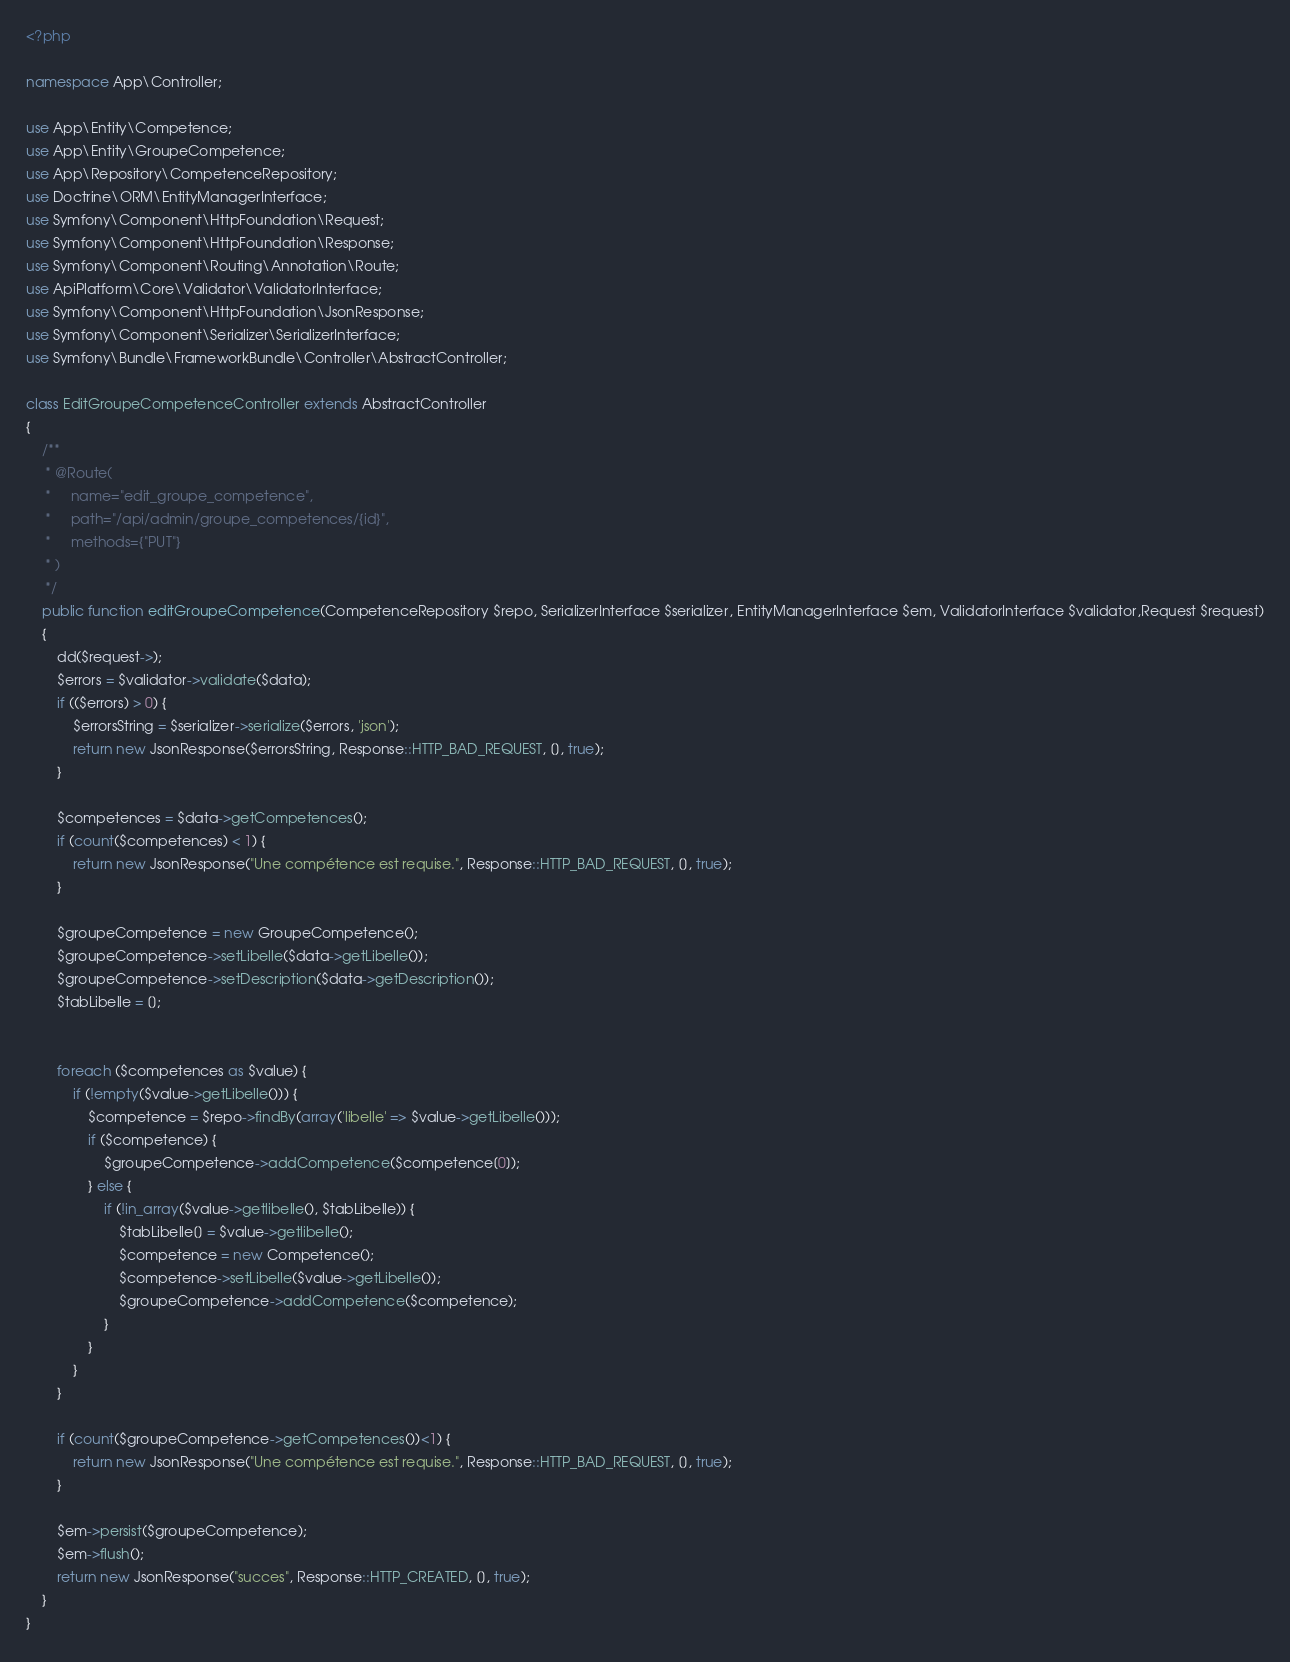<code> <loc_0><loc_0><loc_500><loc_500><_PHP_><?php

namespace App\Controller;

use App\Entity\Competence;
use App\Entity\GroupeCompetence;
use App\Repository\CompetenceRepository;
use Doctrine\ORM\EntityManagerInterface;
use Symfony\Component\HttpFoundation\Request;
use Symfony\Component\HttpFoundation\Response;
use Symfony\Component\Routing\Annotation\Route;
use ApiPlatform\Core\Validator\ValidatorInterface;
use Symfony\Component\HttpFoundation\JsonResponse;
use Symfony\Component\Serializer\SerializerInterface;
use Symfony\Bundle\FrameworkBundle\Controller\AbstractController;

class EditGroupeCompetenceController extends AbstractController
{
    /**
     * @Route(
     *     name="edit_groupe_competence",
     *     path="/api/admin/groupe_competences/{id}",
     *     methods={"PUT"}
     * )
     */
    public function editGroupeCompetence(CompetenceRepository $repo, SerializerInterface $serializer, EntityManagerInterface $em, ValidatorInterface $validator,Request $request)
    {
        dd($request->);
        $errors = $validator->validate($data);
        if (($errors) > 0) {
            $errorsString = $serializer->serialize($errors, 'json');
            return new JsonResponse($errorsString, Response::HTTP_BAD_REQUEST, [], true);
        }

        $competences = $data->getCompetences();
        if (count($competences) < 1) {
            return new JsonResponse("Une compétence est requise.", Response::HTTP_BAD_REQUEST, [], true);
        }

        $groupeCompetence = new GroupeCompetence();
        $groupeCompetence->setLibelle($data->getLibelle());
        $groupeCompetence->setDescription($data->getDescription());
        $tabLibelle = [];


        foreach ($competences as $value) {
            if (!empty($value->getLibelle())) {
                $competence = $repo->findBy(array('libelle' => $value->getLibelle()));
                if ($competence) {
                    $groupeCompetence->addCompetence($competence[0]);
                } else {
                    if (!in_array($value->getlibelle(), $tabLibelle)) {
                        $tabLibelle[] = $value->getlibelle();
                        $competence = new Competence();
                        $competence->setLibelle($value->getLibelle());
                        $groupeCompetence->addCompetence($competence);
                    }
                }
            }
        }

        if (count($groupeCompetence->getCompetences())<1) {
            return new JsonResponse("Une compétence est requise.", Response::HTTP_BAD_REQUEST, [], true);
        }

        $em->persist($groupeCompetence);
        $em->flush();
        return new JsonResponse("succes", Response::HTTP_CREATED, [], true);
    }
}
</code> 